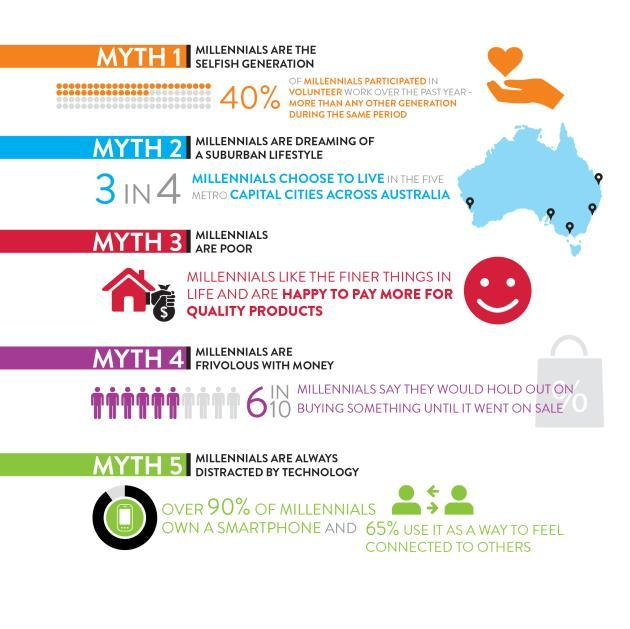What percentage of millennial's have not participated in the volunteer work?
Answer the question with a short phrase. 60 What percent of Millennials does not own a smartphone? 10 What percentage of millennial's does not use smartphone to connect with others? 35 How many millennial's chose not to live in metro capital cities? 1 How many myths are listed in the info graphic? 5 